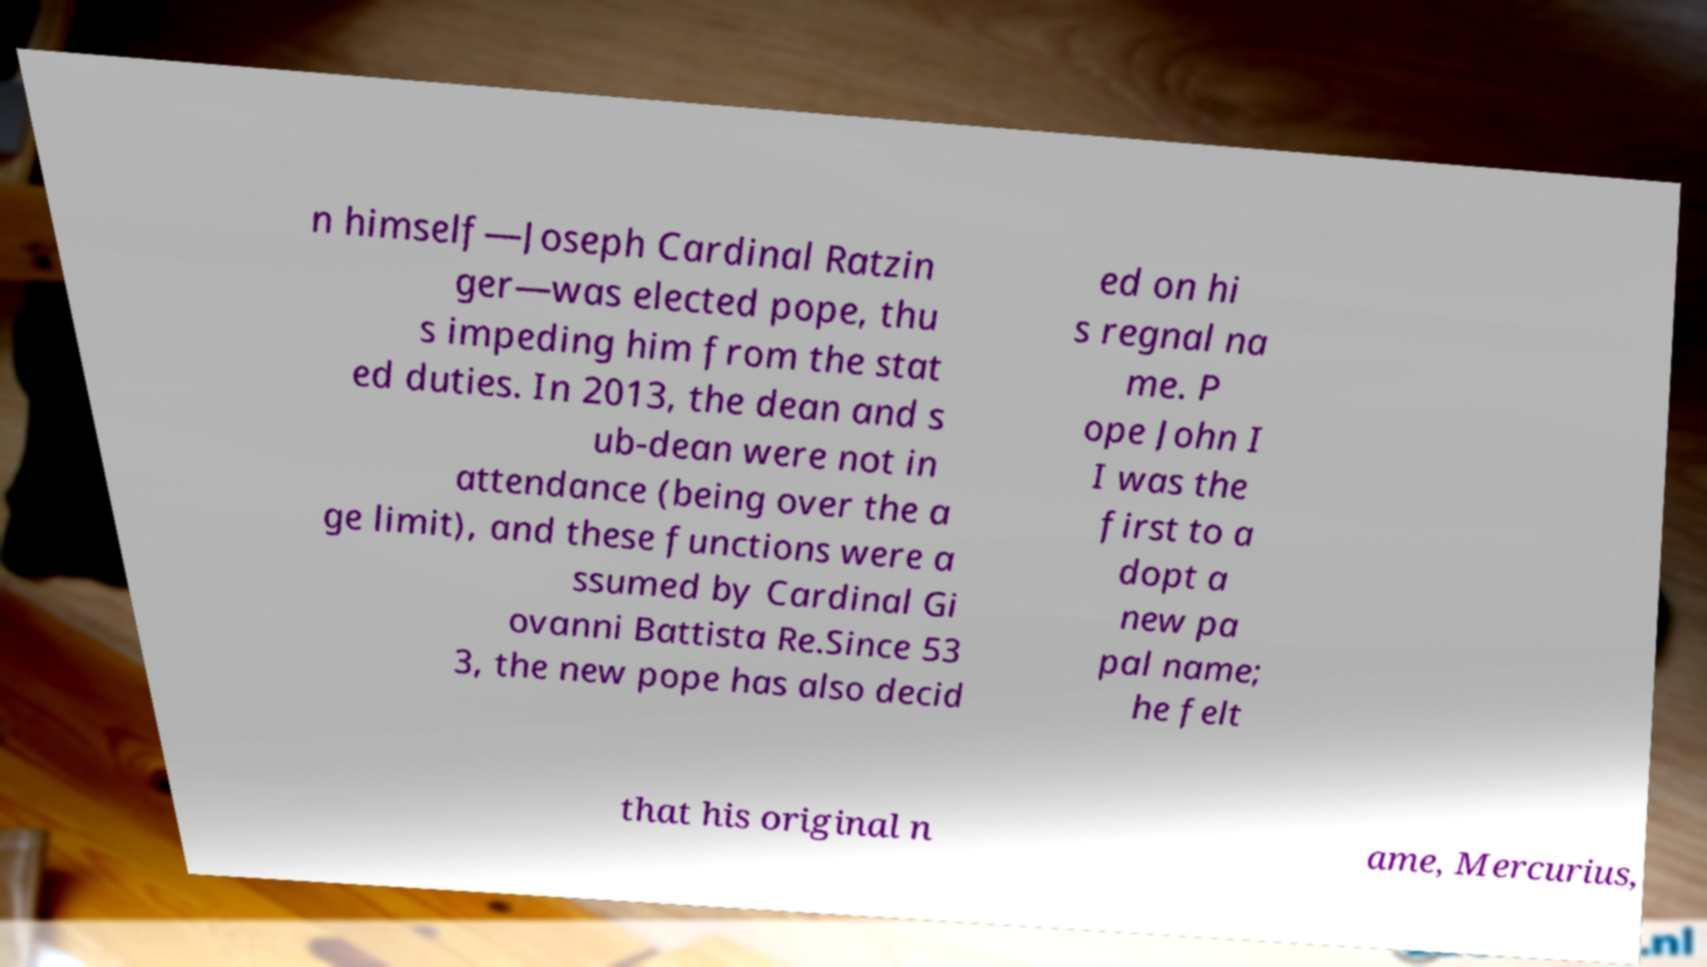What messages or text are displayed in this image? I need them in a readable, typed format. n himself—Joseph Cardinal Ratzin ger—was elected pope, thu s impeding him from the stat ed duties. In 2013, the dean and s ub-dean were not in attendance (being over the a ge limit), and these functions were a ssumed by Cardinal Gi ovanni Battista Re.Since 53 3, the new pope has also decid ed on hi s regnal na me. P ope John I I was the first to a dopt a new pa pal name; he felt that his original n ame, Mercurius, 